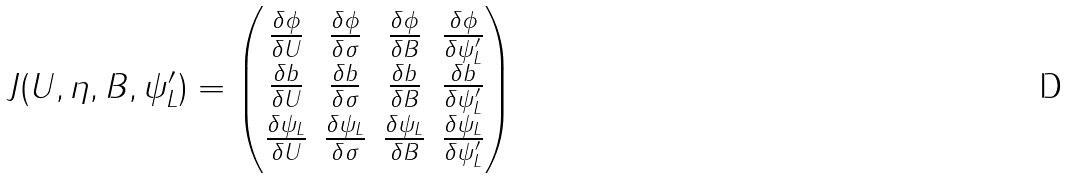<formula> <loc_0><loc_0><loc_500><loc_500>J ( U , \eta , B , \psi _ { L } ^ { \prime } ) = \begin{pmatrix} \frac { \delta \phi } { \delta U } & \frac { \delta \phi } { \delta \sigma } & \frac { \delta \phi } { \delta B } & \frac { \delta \phi } { \delta \psi _ { L } ^ { \prime } } \\ \frac { \delta b } { \delta U } & \frac { \delta b } { \delta \sigma } & \frac { \delta b } { \delta B } & \frac { \delta b } { \delta \psi _ { L } ^ { \prime } } \\ \frac { \delta \psi _ { L } } { \delta U } & \frac { \delta \psi _ { L } } { \delta \sigma } & \frac { \delta \psi _ { L } } { \delta B } & \frac { \delta \psi _ { L } } { \delta \psi _ { L } ^ { \prime } } \end{pmatrix}</formula> 